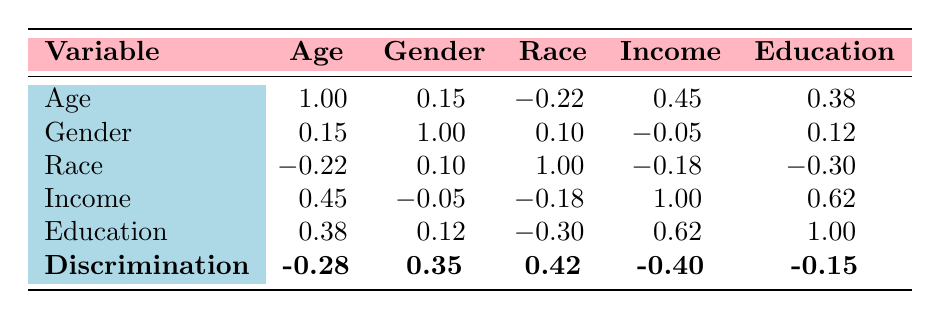What is the correlation coefficient between Age and Reports of Discrimination? The table indicates the correlation coefficient between Age and Reports of Discrimination is -0.28. This means that as Age increases, reports of discrimination tend to decrease slightly.
Answer: -0.28 Which demographic factor has the highest positive correlation with Reports of Discrimination? By examining the correlation coefficients, Gender has the highest positive correlation (0.35) with Reports of Discrimination, indicating that female individuals report discrimination more frequently compared to males or non-binary individuals.
Answer: Gender Is there a correlation between Education Level and Income Level? The correlation coefficient between Education Level and Income Level is 0.62, indicating a strong positive correlation. This indicates that higher education levels are generally associated with higher income levels.
Answer: Yes Which demographic factor shows a negative correlation with Reports of Discrimination? The factors that show a negative correlation with Reports of Discrimination are Age (-0.28) and Income Level (-0.40). This indicates that older individuals and those with higher income levels tend to report discrimination less frequently.
Answer: Age and Income Level What is the average correlation coefficient between all demographic factors and Reports of Discrimination? To find the average coefficient, we sum the correlation coefficients between each demographic factor and Reports of Discrimination: (-0.28 + 0.35 + 0.42 - 0.40 - 0.15) = -0.06. Dividing by 5 yields an average of -0.012.
Answer: -0.012 Does Race have a significant impact on Reports of Discrimination based on the correlation value? The correlation between Race and Reports of Discrimination is 0.42, which indicates a positive relationship suggesting that racial minority groups report discrimination more than others. Hence, Race does have a significant impact.
Answer: Yes What is the lowest correlation value present in the table? The lowest correlation in the table is between Race and Education Level, which is -0.30. This means there's a slight tendency for higher education to be associated with being non-minority in Race.
Answer: -0.30 How does Income Level correlate with Gender in terms of Reports of Discrimination? The correlation between Income Level and Gender is -0.05, indicating that there is virtually no correlation, meaning that in this dataset, neither demographic factor significantly influences another.
Answer: No correlation 